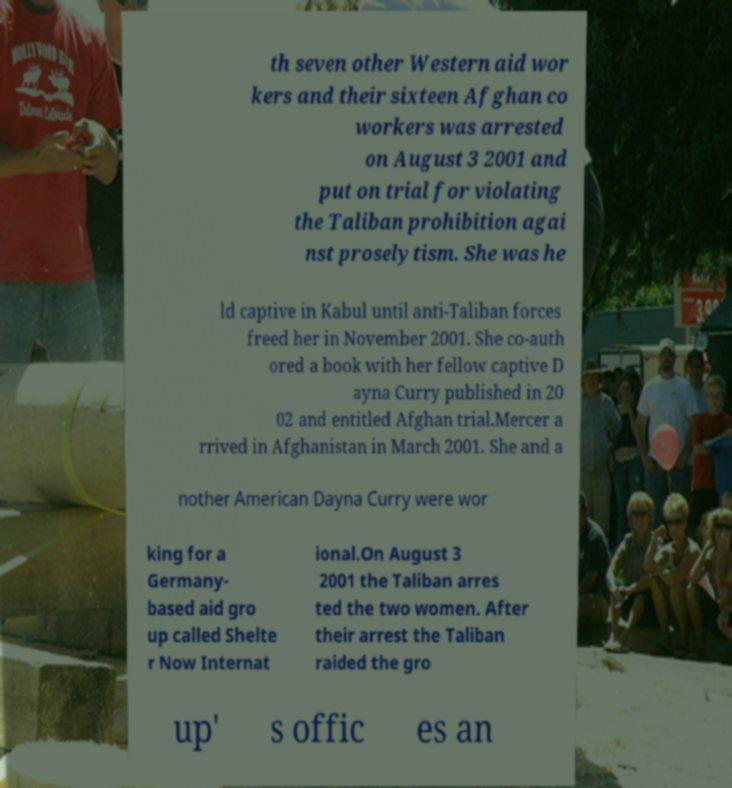Could you extract and type out the text from this image? th seven other Western aid wor kers and their sixteen Afghan co workers was arrested on August 3 2001 and put on trial for violating the Taliban prohibition agai nst proselytism. She was he ld captive in Kabul until anti-Taliban forces freed her in November 2001. She co-auth ored a book with her fellow captive D ayna Curry published in 20 02 and entitled Afghan trial.Mercer a rrived in Afghanistan in March 2001. She and a nother American Dayna Curry were wor king for a Germany- based aid gro up called Shelte r Now Internat ional.On August 3 2001 the Taliban arres ted the two women. After their arrest the Taliban raided the gro up' s offic es an 